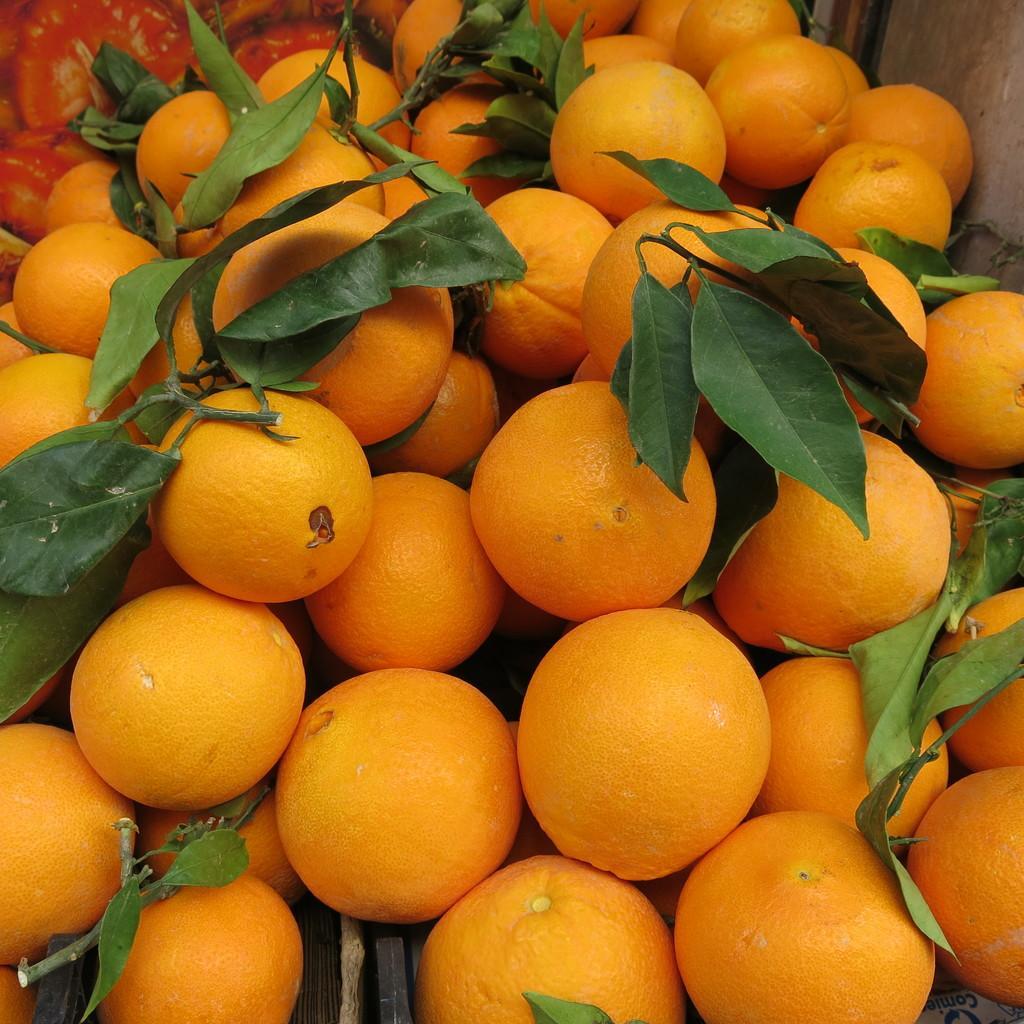Describe this image in one or two sentences. In this image there are many oranges and few leaves are there. 